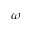Convert formula to latex. <formula><loc_0><loc_0><loc_500><loc_500>\omega</formula> 